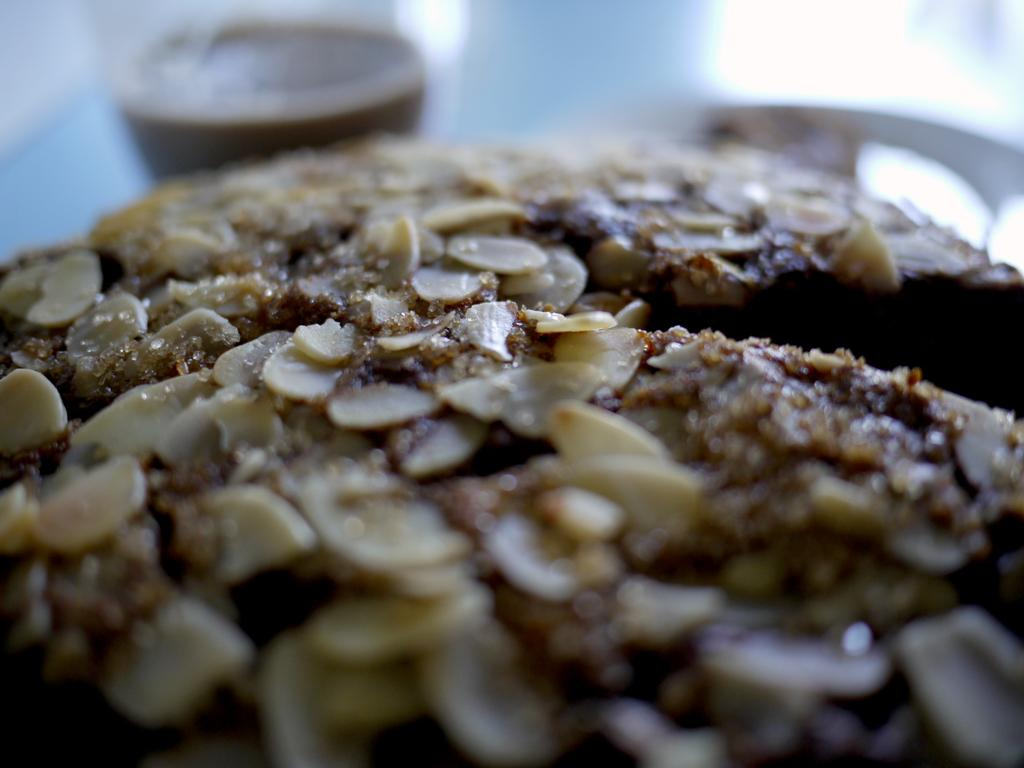What types of objects can be seen in the image? There are food items in the image. Can you describe the background of the image? The background of the image is blurred. What type of truck is visible in the image? There is no truck present in the image. Are there any masks or ornaments featured in the image? There are no masks or ornaments present in the image. 